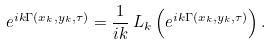<formula> <loc_0><loc_0><loc_500><loc_500>e ^ { i k \Gamma ( x _ { k } , y _ { k } , \tau ) } = \frac { 1 } { i k } \, L _ { k } \left ( e ^ { i k \Gamma ( x _ { k } , y _ { k } , \tau ) } \right ) .</formula> 